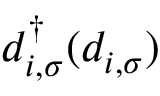<formula> <loc_0><loc_0><loc_500><loc_500>d _ { i , \sigma } ^ { \dag } ( d _ { i , \sigma } )</formula> 